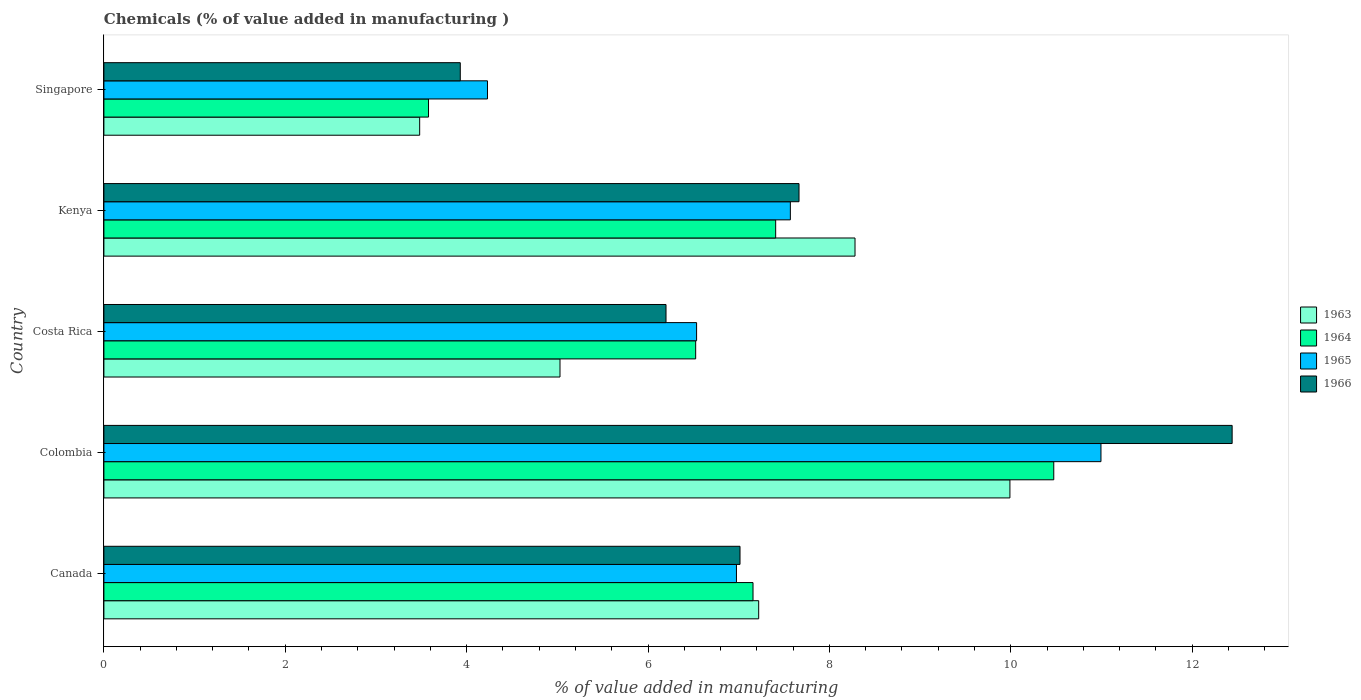How many groups of bars are there?
Offer a very short reply. 5. Are the number of bars per tick equal to the number of legend labels?
Provide a succinct answer. Yes. Are the number of bars on each tick of the Y-axis equal?
Your answer should be compact. Yes. How many bars are there on the 2nd tick from the bottom?
Your answer should be compact. 4. What is the label of the 1st group of bars from the top?
Your answer should be compact. Singapore. In how many cases, is the number of bars for a given country not equal to the number of legend labels?
Keep it short and to the point. 0. What is the value added in manufacturing chemicals in 1963 in Costa Rica?
Offer a terse response. 5.03. Across all countries, what is the maximum value added in manufacturing chemicals in 1965?
Your answer should be very brief. 10.99. Across all countries, what is the minimum value added in manufacturing chemicals in 1963?
Give a very brief answer. 3.48. In which country was the value added in manufacturing chemicals in 1965 maximum?
Provide a short and direct response. Colombia. In which country was the value added in manufacturing chemicals in 1964 minimum?
Ensure brevity in your answer.  Singapore. What is the total value added in manufacturing chemicals in 1966 in the graph?
Your answer should be compact. 37.25. What is the difference between the value added in manufacturing chemicals in 1964 in Canada and that in Kenya?
Offer a terse response. -0.25. What is the difference between the value added in manufacturing chemicals in 1965 in Costa Rica and the value added in manufacturing chemicals in 1963 in Singapore?
Offer a very short reply. 3.05. What is the average value added in manufacturing chemicals in 1965 per country?
Give a very brief answer. 7.26. What is the difference between the value added in manufacturing chemicals in 1964 and value added in manufacturing chemicals in 1963 in Colombia?
Provide a short and direct response. 0.48. What is the ratio of the value added in manufacturing chemicals in 1964 in Colombia to that in Costa Rica?
Your response must be concise. 1.61. Is the value added in manufacturing chemicals in 1966 in Costa Rica less than that in Singapore?
Keep it short and to the point. No. Is the difference between the value added in manufacturing chemicals in 1964 in Kenya and Singapore greater than the difference between the value added in manufacturing chemicals in 1963 in Kenya and Singapore?
Keep it short and to the point. No. What is the difference between the highest and the second highest value added in manufacturing chemicals in 1963?
Keep it short and to the point. 1.71. What is the difference between the highest and the lowest value added in manufacturing chemicals in 1966?
Ensure brevity in your answer.  8.51. In how many countries, is the value added in manufacturing chemicals in 1966 greater than the average value added in manufacturing chemicals in 1966 taken over all countries?
Your answer should be very brief. 2. What does the 1st bar from the top in Canada represents?
Offer a very short reply. 1966. What does the 2nd bar from the bottom in Canada represents?
Offer a terse response. 1964. What is the difference between two consecutive major ticks on the X-axis?
Your answer should be compact. 2. Are the values on the major ticks of X-axis written in scientific E-notation?
Your answer should be very brief. No. Does the graph contain any zero values?
Offer a terse response. No. Where does the legend appear in the graph?
Provide a succinct answer. Center right. How are the legend labels stacked?
Offer a very short reply. Vertical. What is the title of the graph?
Ensure brevity in your answer.  Chemicals (% of value added in manufacturing ). What is the label or title of the X-axis?
Provide a short and direct response. % of value added in manufacturing. What is the % of value added in manufacturing of 1963 in Canada?
Offer a very short reply. 7.22. What is the % of value added in manufacturing in 1964 in Canada?
Offer a terse response. 7.16. What is the % of value added in manufacturing in 1965 in Canada?
Offer a terse response. 6.98. What is the % of value added in manufacturing in 1966 in Canada?
Provide a succinct answer. 7.01. What is the % of value added in manufacturing of 1963 in Colombia?
Your response must be concise. 9.99. What is the % of value added in manufacturing in 1964 in Colombia?
Your response must be concise. 10.47. What is the % of value added in manufacturing in 1965 in Colombia?
Provide a short and direct response. 10.99. What is the % of value added in manufacturing of 1966 in Colombia?
Your answer should be very brief. 12.44. What is the % of value added in manufacturing of 1963 in Costa Rica?
Provide a short and direct response. 5.03. What is the % of value added in manufacturing of 1964 in Costa Rica?
Offer a terse response. 6.53. What is the % of value added in manufacturing of 1965 in Costa Rica?
Your answer should be very brief. 6.54. What is the % of value added in manufacturing in 1966 in Costa Rica?
Provide a succinct answer. 6.2. What is the % of value added in manufacturing of 1963 in Kenya?
Provide a short and direct response. 8.28. What is the % of value added in manufacturing in 1964 in Kenya?
Your answer should be compact. 7.41. What is the % of value added in manufacturing of 1965 in Kenya?
Provide a succinct answer. 7.57. What is the % of value added in manufacturing of 1966 in Kenya?
Keep it short and to the point. 7.67. What is the % of value added in manufacturing in 1963 in Singapore?
Your answer should be compact. 3.48. What is the % of value added in manufacturing in 1964 in Singapore?
Give a very brief answer. 3.58. What is the % of value added in manufacturing in 1965 in Singapore?
Make the answer very short. 4.23. What is the % of value added in manufacturing of 1966 in Singapore?
Provide a succinct answer. 3.93. Across all countries, what is the maximum % of value added in manufacturing in 1963?
Your answer should be very brief. 9.99. Across all countries, what is the maximum % of value added in manufacturing in 1964?
Give a very brief answer. 10.47. Across all countries, what is the maximum % of value added in manufacturing in 1965?
Offer a terse response. 10.99. Across all countries, what is the maximum % of value added in manufacturing in 1966?
Offer a terse response. 12.44. Across all countries, what is the minimum % of value added in manufacturing in 1963?
Provide a succinct answer. 3.48. Across all countries, what is the minimum % of value added in manufacturing in 1964?
Your answer should be very brief. 3.58. Across all countries, what is the minimum % of value added in manufacturing of 1965?
Make the answer very short. 4.23. Across all countries, what is the minimum % of value added in manufacturing of 1966?
Keep it short and to the point. 3.93. What is the total % of value added in manufacturing of 1963 in the graph?
Provide a short and direct response. 34.01. What is the total % of value added in manufacturing of 1964 in the graph?
Your response must be concise. 35.15. What is the total % of value added in manufacturing in 1965 in the graph?
Your answer should be compact. 36.31. What is the total % of value added in manufacturing in 1966 in the graph?
Provide a succinct answer. 37.25. What is the difference between the % of value added in manufacturing in 1963 in Canada and that in Colombia?
Provide a short and direct response. -2.77. What is the difference between the % of value added in manufacturing in 1964 in Canada and that in Colombia?
Your answer should be compact. -3.32. What is the difference between the % of value added in manufacturing in 1965 in Canada and that in Colombia?
Your answer should be compact. -4.02. What is the difference between the % of value added in manufacturing of 1966 in Canada and that in Colombia?
Your answer should be compact. -5.43. What is the difference between the % of value added in manufacturing in 1963 in Canada and that in Costa Rica?
Provide a short and direct response. 2.19. What is the difference between the % of value added in manufacturing of 1964 in Canada and that in Costa Rica?
Provide a succinct answer. 0.63. What is the difference between the % of value added in manufacturing of 1965 in Canada and that in Costa Rica?
Make the answer very short. 0.44. What is the difference between the % of value added in manufacturing in 1966 in Canada and that in Costa Rica?
Offer a terse response. 0.82. What is the difference between the % of value added in manufacturing of 1963 in Canada and that in Kenya?
Your answer should be compact. -1.06. What is the difference between the % of value added in manufacturing in 1964 in Canada and that in Kenya?
Offer a terse response. -0.25. What is the difference between the % of value added in manufacturing of 1965 in Canada and that in Kenya?
Give a very brief answer. -0.59. What is the difference between the % of value added in manufacturing in 1966 in Canada and that in Kenya?
Your response must be concise. -0.65. What is the difference between the % of value added in manufacturing in 1963 in Canada and that in Singapore?
Ensure brevity in your answer.  3.74. What is the difference between the % of value added in manufacturing of 1964 in Canada and that in Singapore?
Your response must be concise. 3.58. What is the difference between the % of value added in manufacturing of 1965 in Canada and that in Singapore?
Provide a short and direct response. 2.75. What is the difference between the % of value added in manufacturing of 1966 in Canada and that in Singapore?
Your answer should be very brief. 3.08. What is the difference between the % of value added in manufacturing of 1963 in Colombia and that in Costa Rica?
Your answer should be compact. 4.96. What is the difference between the % of value added in manufacturing in 1964 in Colombia and that in Costa Rica?
Your response must be concise. 3.95. What is the difference between the % of value added in manufacturing of 1965 in Colombia and that in Costa Rica?
Offer a terse response. 4.46. What is the difference between the % of value added in manufacturing of 1966 in Colombia and that in Costa Rica?
Your response must be concise. 6.24. What is the difference between the % of value added in manufacturing of 1963 in Colombia and that in Kenya?
Provide a short and direct response. 1.71. What is the difference between the % of value added in manufacturing in 1964 in Colombia and that in Kenya?
Provide a succinct answer. 3.07. What is the difference between the % of value added in manufacturing in 1965 in Colombia and that in Kenya?
Your answer should be compact. 3.43. What is the difference between the % of value added in manufacturing in 1966 in Colombia and that in Kenya?
Your response must be concise. 4.78. What is the difference between the % of value added in manufacturing of 1963 in Colombia and that in Singapore?
Offer a terse response. 6.51. What is the difference between the % of value added in manufacturing of 1964 in Colombia and that in Singapore?
Keep it short and to the point. 6.89. What is the difference between the % of value added in manufacturing of 1965 in Colombia and that in Singapore?
Ensure brevity in your answer.  6.76. What is the difference between the % of value added in manufacturing in 1966 in Colombia and that in Singapore?
Make the answer very short. 8.51. What is the difference between the % of value added in manufacturing of 1963 in Costa Rica and that in Kenya?
Your answer should be very brief. -3.25. What is the difference between the % of value added in manufacturing in 1964 in Costa Rica and that in Kenya?
Offer a terse response. -0.88. What is the difference between the % of value added in manufacturing of 1965 in Costa Rica and that in Kenya?
Your answer should be very brief. -1.03. What is the difference between the % of value added in manufacturing in 1966 in Costa Rica and that in Kenya?
Your answer should be compact. -1.47. What is the difference between the % of value added in manufacturing of 1963 in Costa Rica and that in Singapore?
Make the answer very short. 1.55. What is the difference between the % of value added in manufacturing in 1964 in Costa Rica and that in Singapore?
Offer a very short reply. 2.95. What is the difference between the % of value added in manufacturing of 1965 in Costa Rica and that in Singapore?
Provide a succinct answer. 2.31. What is the difference between the % of value added in manufacturing of 1966 in Costa Rica and that in Singapore?
Provide a succinct answer. 2.27. What is the difference between the % of value added in manufacturing of 1963 in Kenya and that in Singapore?
Ensure brevity in your answer.  4.8. What is the difference between the % of value added in manufacturing of 1964 in Kenya and that in Singapore?
Give a very brief answer. 3.83. What is the difference between the % of value added in manufacturing of 1965 in Kenya and that in Singapore?
Give a very brief answer. 3.34. What is the difference between the % of value added in manufacturing of 1966 in Kenya and that in Singapore?
Make the answer very short. 3.74. What is the difference between the % of value added in manufacturing in 1963 in Canada and the % of value added in manufacturing in 1964 in Colombia?
Provide a succinct answer. -3.25. What is the difference between the % of value added in manufacturing of 1963 in Canada and the % of value added in manufacturing of 1965 in Colombia?
Offer a terse response. -3.77. What is the difference between the % of value added in manufacturing in 1963 in Canada and the % of value added in manufacturing in 1966 in Colombia?
Your answer should be compact. -5.22. What is the difference between the % of value added in manufacturing in 1964 in Canada and the % of value added in manufacturing in 1965 in Colombia?
Give a very brief answer. -3.84. What is the difference between the % of value added in manufacturing of 1964 in Canada and the % of value added in manufacturing of 1966 in Colombia?
Offer a terse response. -5.28. What is the difference between the % of value added in manufacturing of 1965 in Canada and the % of value added in manufacturing of 1966 in Colombia?
Ensure brevity in your answer.  -5.47. What is the difference between the % of value added in manufacturing of 1963 in Canada and the % of value added in manufacturing of 1964 in Costa Rica?
Keep it short and to the point. 0.69. What is the difference between the % of value added in manufacturing of 1963 in Canada and the % of value added in manufacturing of 1965 in Costa Rica?
Give a very brief answer. 0.68. What is the difference between the % of value added in manufacturing in 1963 in Canada and the % of value added in manufacturing in 1966 in Costa Rica?
Offer a very short reply. 1.02. What is the difference between the % of value added in manufacturing of 1964 in Canada and the % of value added in manufacturing of 1965 in Costa Rica?
Your answer should be compact. 0.62. What is the difference between the % of value added in manufacturing in 1964 in Canada and the % of value added in manufacturing in 1966 in Costa Rica?
Make the answer very short. 0.96. What is the difference between the % of value added in manufacturing of 1965 in Canada and the % of value added in manufacturing of 1966 in Costa Rica?
Your answer should be very brief. 0.78. What is the difference between the % of value added in manufacturing in 1963 in Canada and the % of value added in manufacturing in 1964 in Kenya?
Make the answer very short. -0.19. What is the difference between the % of value added in manufacturing of 1963 in Canada and the % of value added in manufacturing of 1965 in Kenya?
Keep it short and to the point. -0.35. What is the difference between the % of value added in manufacturing of 1963 in Canada and the % of value added in manufacturing of 1966 in Kenya?
Offer a terse response. -0.44. What is the difference between the % of value added in manufacturing in 1964 in Canada and the % of value added in manufacturing in 1965 in Kenya?
Your answer should be compact. -0.41. What is the difference between the % of value added in manufacturing of 1964 in Canada and the % of value added in manufacturing of 1966 in Kenya?
Your response must be concise. -0.51. What is the difference between the % of value added in manufacturing of 1965 in Canada and the % of value added in manufacturing of 1966 in Kenya?
Offer a terse response. -0.69. What is the difference between the % of value added in manufacturing in 1963 in Canada and the % of value added in manufacturing in 1964 in Singapore?
Provide a succinct answer. 3.64. What is the difference between the % of value added in manufacturing in 1963 in Canada and the % of value added in manufacturing in 1965 in Singapore?
Offer a very short reply. 2.99. What is the difference between the % of value added in manufacturing of 1963 in Canada and the % of value added in manufacturing of 1966 in Singapore?
Your response must be concise. 3.29. What is the difference between the % of value added in manufacturing of 1964 in Canada and the % of value added in manufacturing of 1965 in Singapore?
Your answer should be compact. 2.93. What is the difference between the % of value added in manufacturing of 1964 in Canada and the % of value added in manufacturing of 1966 in Singapore?
Your answer should be compact. 3.23. What is the difference between the % of value added in manufacturing in 1965 in Canada and the % of value added in manufacturing in 1966 in Singapore?
Offer a very short reply. 3.05. What is the difference between the % of value added in manufacturing in 1963 in Colombia and the % of value added in manufacturing in 1964 in Costa Rica?
Provide a short and direct response. 3.47. What is the difference between the % of value added in manufacturing of 1963 in Colombia and the % of value added in manufacturing of 1965 in Costa Rica?
Give a very brief answer. 3.46. What is the difference between the % of value added in manufacturing of 1963 in Colombia and the % of value added in manufacturing of 1966 in Costa Rica?
Offer a very short reply. 3.79. What is the difference between the % of value added in manufacturing in 1964 in Colombia and the % of value added in manufacturing in 1965 in Costa Rica?
Your answer should be very brief. 3.94. What is the difference between the % of value added in manufacturing of 1964 in Colombia and the % of value added in manufacturing of 1966 in Costa Rica?
Offer a very short reply. 4.28. What is the difference between the % of value added in manufacturing in 1965 in Colombia and the % of value added in manufacturing in 1966 in Costa Rica?
Give a very brief answer. 4.8. What is the difference between the % of value added in manufacturing in 1963 in Colombia and the % of value added in manufacturing in 1964 in Kenya?
Provide a short and direct response. 2.58. What is the difference between the % of value added in manufacturing of 1963 in Colombia and the % of value added in manufacturing of 1965 in Kenya?
Provide a short and direct response. 2.42. What is the difference between the % of value added in manufacturing of 1963 in Colombia and the % of value added in manufacturing of 1966 in Kenya?
Ensure brevity in your answer.  2.33. What is the difference between the % of value added in manufacturing of 1964 in Colombia and the % of value added in manufacturing of 1965 in Kenya?
Offer a very short reply. 2.9. What is the difference between the % of value added in manufacturing in 1964 in Colombia and the % of value added in manufacturing in 1966 in Kenya?
Your response must be concise. 2.81. What is the difference between the % of value added in manufacturing in 1965 in Colombia and the % of value added in manufacturing in 1966 in Kenya?
Provide a short and direct response. 3.33. What is the difference between the % of value added in manufacturing in 1963 in Colombia and the % of value added in manufacturing in 1964 in Singapore?
Your answer should be compact. 6.41. What is the difference between the % of value added in manufacturing in 1963 in Colombia and the % of value added in manufacturing in 1965 in Singapore?
Your response must be concise. 5.76. What is the difference between the % of value added in manufacturing of 1963 in Colombia and the % of value added in manufacturing of 1966 in Singapore?
Give a very brief answer. 6.06. What is the difference between the % of value added in manufacturing in 1964 in Colombia and the % of value added in manufacturing in 1965 in Singapore?
Keep it short and to the point. 6.24. What is the difference between the % of value added in manufacturing of 1964 in Colombia and the % of value added in manufacturing of 1966 in Singapore?
Provide a short and direct response. 6.54. What is the difference between the % of value added in manufacturing of 1965 in Colombia and the % of value added in manufacturing of 1966 in Singapore?
Provide a succinct answer. 7.07. What is the difference between the % of value added in manufacturing of 1963 in Costa Rica and the % of value added in manufacturing of 1964 in Kenya?
Provide a succinct answer. -2.38. What is the difference between the % of value added in manufacturing of 1963 in Costa Rica and the % of value added in manufacturing of 1965 in Kenya?
Your response must be concise. -2.54. What is the difference between the % of value added in manufacturing in 1963 in Costa Rica and the % of value added in manufacturing in 1966 in Kenya?
Offer a very short reply. -2.64. What is the difference between the % of value added in manufacturing in 1964 in Costa Rica and the % of value added in manufacturing in 1965 in Kenya?
Ensure brevity in your answer.  -1.04. What is the difference between the % of value added in manufacturing of 1964 in Costa Rica and the % of value added in manufacturing of 1966 in Kenya?
Ensure brevity in your answer.  -1.14. What is the difference between the % of value added in manufacturing of 1965 in Costa Rica and the % of value added in manufacturing of 1966 in Kenya?
Offer a very short reply. -1.13. What is the difference between the % of value added in manufacturing of 1963 in Costa Rica and the % of value added in manufacturing of 1964 in Singapore?
Provide a succinct answer. 1.45. What is the difference between the % of value added in manufacturing of 1963 in Costa Rica and the % of value added in manufacturing of 1965 in Singapore?
Keep it short and to the point. 0.8. What is the difference between the % of value added in manufacturing in 1963 in Costa Rica and the % of value added in manufacturing in 1966 in Singapore?
Make the answer very short. 1.1. What is the difference between the % of value added in manufacturing of 1964 in Costa Rica and the % of value added in manufacturing of 1965 in Singapore?
Keep it short and to the point. 2.3. What is the difference between the % of value added in manufacturing of 1964 in Costa Rica and the % of value added in manufacturing of 1966 in Singapore?
Your response must be concise. 2.6. What is the difference between the % of value added in manufacturing of 1965 in Costa Rica and the % of value added in manufacturing of 1966 in Singapore?
Provide a succinct answer. 2.61. What is the difference between the % of value added in manufacturing of 1963 in Kenya and the % of value added in manufacturing of 1964 in Singapore?
Keep it short and to the point. 4.7. What is the difference between the % of value added in manufacturing of 1963 in Kenya and the % of value added in manufacturing of 1965 in Singapore?
Offer a very short reply. 4.05. What is the difference between the % of value added in manufacturing of 1963 in Kenya and the % of value added in manufacturing of 1966 in Singapore?
Ensure brevity in your answer.  4.35. What is the difference between the % of value added in manufacturing in 1964 in Kenya and the % of value added in manufacturing in 1965 in Singapore?
Provide a short and direct response. 3.18. What is the difference between the % of value added in manufacturing in 1964 in Kenya and the % of value added in manufacturing in 1966 in Singapore?
Make the answer very short. 3.48. What is the difference between the % of value added in manufacturing of 1965 in Kenya and the % of value added in manufacturing of 1966 in Singapore?
Offer a terse response. 3.64. What is the average % of value added in manufacturing in 1963 per country?
Offer a very short reply. 6.8. What is the average % of value added in manufacturing in 1964 per country?
Offer a very short reply. 7.03. What is the average % of value added in manufacturing of 1965 per country?
Offer a very short reply. 7.26. What is the average % of value added in manufacturing of 1966 per country?
Keep it short and to the point. 7.45. What is the difference between the % of value added in manufacturing in 1963 and % of value added in manufacturing in 1964 in Canada?
Offer a very short reply. 0.06. What is the difference between the % of value added in manufacturing in 1963 and % of value added in manufacturing in 1965 in Canada?
Ensure brevity in your answer.  0.25. What is the difference between the % of value added in manufacturing of 1963 and % of value added in manufacturing of 1966 in Canada?
Your answer should be compact. 0.21. What is the difference between the % of value added in manufacturing in 1964 and % of value added in manufacturing in 1965 in Canada?
Your answer should be compact. 0.18. What is the difference between the % of value added in manufacturing in 1964 and % of value added in manufacturing in 1966 in Canada?
Keep it short and to the point. 0.14. What is the difference between the % of value added in manufacturing in 1965 and % of value added in manufacturing in 1966 in Canada?
Your response must be concise. -0.04. What is the difference between the % of value added in manufacturing in 1963 and % of value added in manufacturing in 1964 in Colombia?
Make the answer very short. -0.48. What is the difference between the % of value added in manufacturing of 1963 and % of value added in manufacturing of 1965 in Colombia?
Give a very brief answer. -1. What is the difference between the % of value added in manufacturing of 1963 and % of value added in manufacturing of 1966 in Colombia?
Give a very brief answer. -2.45. What is the difference between the % of value added in manufacturing in 1964 and % of value added in manufacturing in 1965 in Colombia?
Your response must be concise. -0.52. What is the difference between the % of value added in manufacturing of 1964 and % of value added in manufacturing of 1966 in Colombia?
Keep it short and to the point. -1.97. What is the difference between the % of value added in manufacturing in 1965 and % of value added in manufacturing in 1966 in Colombia?
Provide a short and direct response. -1.45. What is the difference between the % of value added in manufacturing of 1963 and % of value added in manufacturing of 1964 in Costa Rica?
Your response must be concise. -1.5. What is the difference between the % of value added in manufacturing in 1963 and % of value added in manufacturing in 1965 in Costa Rica?
Give a very brief answer. -1.51. What is the difference between the % of value added in manufacturing of 1963 and % of value added in manufacturing of 1966 in Costa Rica?
Your answer should be compact. -1.17. What is the difference between the % of value added in manufacturing of 1964 and % of value added in manufacturing of 1965 in Costa Rica?
Provide a short and direct response. -0.01. What is the difference between the % of value added in manufacturing in 1964 and % of value added in manufacturing in 1966 in Costa Rica?
Provide a short and direct response. 0.33. What is the difference between the % of value added in manufacturing in 1965 and % of value added in manufacturing in 1966 in Costa Rica?
Offer a very short reply. 0.34. What is the difference between the % of value added in manufacturing in 1963 and % of value added in manufacturing in 1964 in Kenya?
Your answer should be compact. 0.87. What is the difference between the % of value added in manufacturing in 1963 and % of value added in manufacturing in 1965 in Kenya?
Make the answer very short. 0.71. What is the difference between the % of value added in manufacturing of 1963 and % of value added in manufacturing of 1966 in Kenya?
Ensure brevity in your answer.  0.62. What is the difference between the % of value added in manufacturing of 1964 and % of value added in manufacturing of 1965 in Kenya?
Make the answer very short. -0.16. What is the difference between the % of value added in manufacturing of 1964 and % of value added in manufacturing of 1966 in Kenya?
Offer a very short reply. -0.26. What is the difference between the % of value added in manufacturing in 1965 and % of value added in manufacturing in 1966 in Kenya?
Give a very brief answer. -0.1. What is the difference between the % of value added in manufacturing in 1963 and % of value added in manufacturing in 1964 in Singapore?
Offer a very short reply. -0.1. What is the difference between the % of value added in manufacturing of 1963 and % of value added in manufacturing of 1965 in Singapore?
Keep it short and to the point. -0.75. What is the difference between the % of value added in manufacturing of 1963 and % of value added in manufacturing of 1966 in Singapore?
Your answer should be compact. -0.45. What is the difference between the % of value added in manufacturing of 1964 and % of value added in manufacturing of 1965 in Singapore?
Provide a succinct answer. -0.65. What is the difference between the % of value added in manufacturing of 1964 and % of value added in manufacturing of 1966 in Singapore?
Keep it short and to the point. -0.35. What is the difference between the % of value added in manufacturing in 1965 and % of value added in manufacturing in 1966 in Singapore?
Keep it short and to the point. 0.3. What is the ratio of the % of value added in manufacturing of 1963 in Canada to that in Colombia?
Your answer should be very brief. 0.72. What is the ratio of the % of value added in manufacturing in 1964 in Canada to that in Colombia?
Offer a terse response. 0.68. What is the ratio of the % of value added in manufacturing of 1965 in Canada to that in Colombia?
Offer a very short reply. 0.63. What is the ratio of the % of value added in manufacturing of 1966 in Canada to that in Colombia?
Your answer should be very brief. 0.56. What is the ratio of the % of value added in manufacturing in 1963 in Canada to that in Costa Rica?
Offer a terse response. 1.44. What is the ratio of the % of value added in manufacturing of 1964 in Canada to that in Costa Rica?
Make the answer very short. 1.1. What is the ratio of the % of value added in manufacturing in 1965 in Canada to that in Costa Rica?
Your response must be concise. 1.07. What is the ratio of the % of value added in manufacturing of 1966 in Canada to that in Costa Rica?
Provide a succinct answer. 1.13. What is the ratio of the % of value added in manufacturing of 1963 in Canada to that in Kenya?
Offer a very short reply. 0.87. What is the ratio of the % of value added in manufacturing in 1964 in Canada to that in Kenya?
Make the answer very short. 0.97. What is the ratio of the % of value added in manufacturing of 1965 in Canada to that in Kenya?
Your answer should be very brief. 0.92. What is the ratio of the % of value added in manufacturing of 1966 in Canada to that in Kenya?
Offer a very short reply. 0.92. What is the ratio of the % of value added in manufacturing of 1963 in Canada to that in Singapore?
Keep it short and to the point. 2.07. What is the ratio of the % of value added in manufacturing in 1964 in Canada to that in Singapore?
Provide a short and direct response. 2. What is the ratio of the % of value added in manufacturing of 1965 in Canada to that in Singapore?
Keep it short and to the point. 1.65. What is the ratio of the % of value added in manufacturing in 1966 in Canada to that in Singapore?
Make the answer very short. 1.78. What is the ratio of the % of value added in manufacturing of 1963 in Colombia to that in Costa Rica?
Give a very brief answer. 1.99. What is the ratio of the % of value added in manufacturing of 1964 in Colombia to that in Costa Rica?
Provide a short and direct response. 1.61. What is the ratio of the % of value added in manufacturing of 1965 in Colombia to that in Costa Rica?
Ensure brevity in your answer.  1.68. What is the ratio of the % of value added in manufacturing in 1966 in Colombia to that in Costa Rica?
Offer a very short reply. 2.01. What is the ratio of the % of value added in manufacturing of 1963 in Colombia to that in Kenya?
Provide a short and direct response. 1.21. What is the ratio of the % of value added in manufacturing in 1964 in Colombia to that in Kenya?
Offer a very short reply. 1.41. What is the ratio of the % of value added in manufacturing of 1965 in Colombia to that in Kenya?
Provide a short and direct response. 1.45. What is the ratio of the % of value added in manufacturing of 1966 in Colombia to that in Kenya?
Your answer should be compact. 1.62. What is the ratio of the % of value added in manufacturing in 1963 in Colombia to that in Singapore?
Provide a succinct answer. 2.87. What is the ratio of the % of value added in manufacturing of 1964 in Colombia to that in Singapore?
Provide a short and direct response. 2.93. What is the ratio of the % of value added in manufacturing in 1965 in Colombia to that in Singapore?
Provide a short and direct response. 2.6. What is the ratio of the % of value added in manufacturing of 1966 in Colombia to that in Singapore?
Provide a succinct answer. 3.17. What is the ratio of the % of value added in manufacturing in 1963 in Costa Rica to that in Kenya?
Ensure brevity in your answer.  0.61. What is the ratio of the % of value added in manufacturing of 1964 in Costa Rica to that in Kenya?
Your response must be concise. 0.88. What is the ratio of the % of value added in manufacturing in 1965 in Costa Rica to that in Kenya?
Keep it short and to the point. 0.86. What is the ratio of the % of value added in manufacturing of 1966 in Costa Rica to that in Kenya?
Your answer should be very brief. 0.81. What is the ratio of the % of value added in manufacturing in 1963 in Costa Rica to that in Singapore?
Offer a very short reply. 1.44. What is the ratio of the % of value added in manufacturing in 1964 in Costa Rica to that in Singapore?
Your answer should be very brief. 1.82. What is the ratio of the % of value added in manufacturing in 1965 in Costa Rica to that in Singapore?
Provide a short and direct response. 1.55. What is the ratio of the % of value added in manufacturing of 1966 in Costa Rica to that in Singapore?
Ensure brevity in your answer.  1.58. What is the ratio of the % of value added in manufacturing of 1963 in Kenya to that in Singapore?
Offer a very short reply. 2.38. What is the ratio of the % of value added in manufacturing of 1964 in Kenya to that in Singapore?
Keep it short and to the point. 2.07. What is the ratio of the % of value added in manufacturing of 1965 in Kenya to that in Singapore?
Give a very brief answer. 1.79. What is the ratio of the % of value added in manufacturing of 1966 in Kenya to that in Singapore?
Your answer should be compact. 1.95. What is the difference between the highest and the second highest % of value added in manufacturing in 1963?
Ensure brevity in your answer.  1.71. What is the difference between the highest and the second highest % of value added in manufacturing in 1964?
Make the answer very short. 3.07. What is the difference between the highest and the second highest % of value added in manufacturing of 1965?
Ensure brevity in your answer.  3.43. What is the difference between the highest and the second highest % of value added in manufacturing in 1966?
Your answer should be compact. 4.78. What is the difference between the highest and the lowest % of value added in manufacturing in 1963?
Offer a very short reply. 6.51. What is the difference between the highest and the lowest % of value added in manufacturing in 1964?
Make the answer very short. 6.89. What is the difference between the highest and the lowest % of value added in manufacturing of 1965?
Ensure brevity in your answer.  6.76. What is the difference between the highest and the lowest % of value added in manufacturing of 1966?
Your response must be concise. 8.51. 